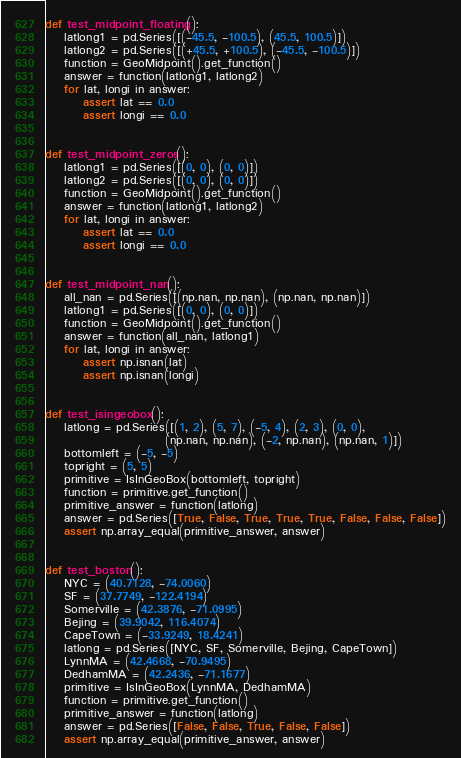Convert code to text. <code><loc_0><loc_0><loc_500><loc_500><_Python_>
def test_midpoint_floating():
    latlong1 = pd.Series([(-45.5, -100.5), (45.5, 100.5)])
    latlong2 = pd.Series([(+45.5, +100.5), (-45.5, -100.5)])
    function = GeoMidpoint().get_function()
    answer = function(latlong1, latlong2)
    for lat, longi in answer:
        assert lat == 0.0
        assert longi == 0.0


def test_midpoint_zeros():
    latlong1 = pd.Series([(0, 0), (0, 0)])
    latlong2 = pd.Series([(0, 0), (0, 0)])
    function = GeoMidpoint().get_function()
    answer = function(latlong1, latlong2)
    for lat, longi in answer:
        assert lat == 0.0
        assert longi == 0.0


def test_midpoint_nan():
    all_nan = pd.Series([(np.nan, np.nan), (np.nan, np.nan)])
    latlong1 = pd.Series([(0, 0), (0, 0)])
    function = GeoMidpoint().get_function()
    answer = function(all_nan, latlong1)
    for lat, longi in answer:
        assert np.isnan(lat)
        assert np.isnan(longi)


def test_isingeobox():
    latlong = pd.Series([(1, 2), (5, 7), (-5, 4), (2, 3), (0, 0),
                         (np.nan, np.nan), (-2, np.nan), (np.nan, 1)])
    bottomleft = (-5, -5)
    topright = (5, 5)
    primitive = IsInGeoBox(bottomleft, topright)
    function = primitive.get_function()
    primitive_answer = function(latlong)
    answer = pd.Series([True, False, True, True, True, False, False, False])
    assert np.array_equal(primitive_answer, answer)


def test_boston():
    NYC = (40.7128, -74.0060)
    SF = (37.7749, -122.4194)
    Somerville = (42.3876, -71.0995)
    Bejing = (39.9042, 116.4074)
    CapeTown = (-33.9249, 18.4241)
    latlong = pd.Series([NYC, SF, Somerville, Bejing, CapeTown])
    LynnMA = (42.4668, -70.9495)
    DedhamMA = (42.2436, -71.1677)
    primitive = IsInGeoBox(LynnMA, DedhamMA)
    function = primitive.get_function()
    primitive_answer = function(latlong)
    answer = pd.Series([False, False, True, False, False])
    assert np.array_equal(primitive_answer, answer)
</code> 